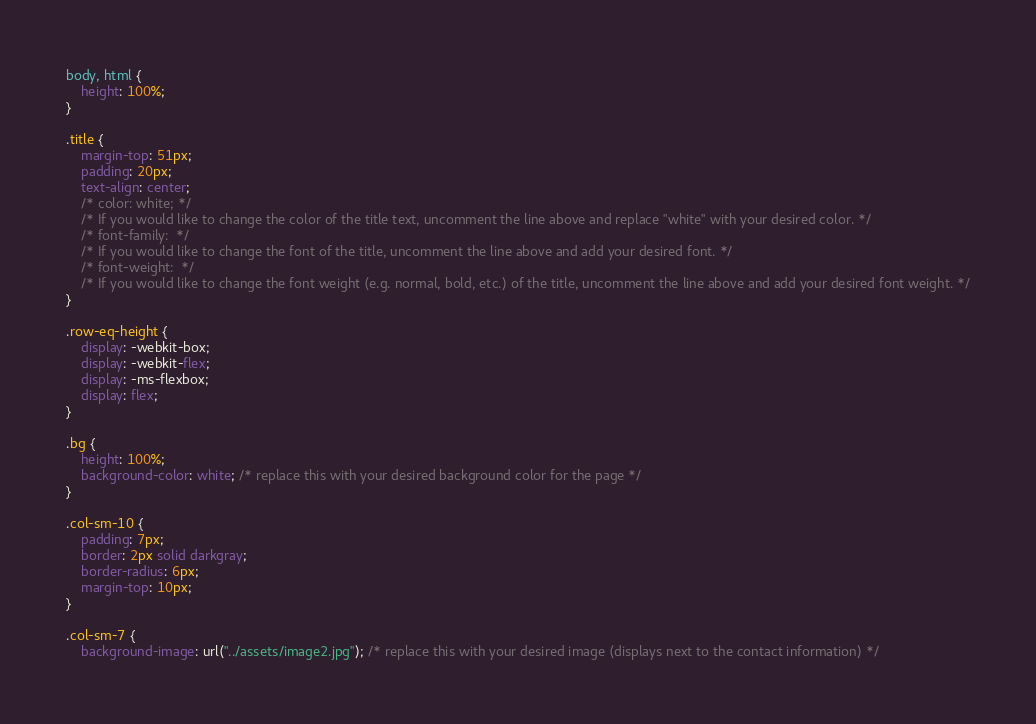<code> <loc_0><loc_0><loc_500><loc_500><_CSS_>body, html {
    height: 100%;
}

.title {
    margin-top: 51px;
    padding: 20px;
    text-align: center;
    /* color: white; */
    /* If you would like to change the color of the title text, uncomment the line above and replace "white" with your desired color. */
    /* font-family:  */
    /* If you would like to change the font of the title, uncomment the line above and add your desired font. */
    /* font-weight:  */
    /* If you would like to change the font weight (e.g. normal, bold, etc.) of the title, uncomment the line above and add your desired font weight. */
}

.row-eq-height {
    display: -webkit-box;
    display: -webkit-flex;
    display: -ms-flexbox;
    display: flex;
}

.bg {
    height: 100%;
    background-color: white; /* replace this with your desired background color for the page */
}

.col-sm-10 {
    padding: 7px;
    border: 2px solid darkgray;
    border-radius: 6px;
    margin-top: 10px;
}

.col-sm-7 {
    background-image: url("../assets/image2.jpg"); /* replace this with your desired image (displays next to the contact information) */</code> 